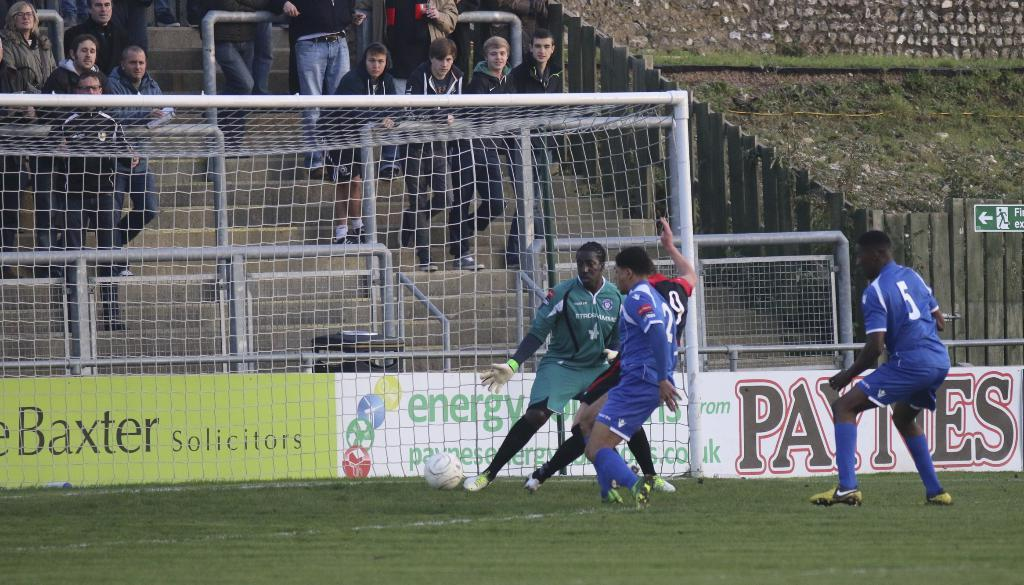What activity are the people in the image engaged in? The people in the image are playing football. Can you describe the setting of the image? There is grass visible in the image, which suggests it is an outdoor location. Are there any other people present in the image? Yes, there are people standing in the background of the image. What type of locket can be seen hanging from the goalpost in the image? There is no locket present in the image, as it features people playing football on a grassy field. How many boats are visible in the image? There are no boats visible in the image; it focuses on a football game taking place on grass. 